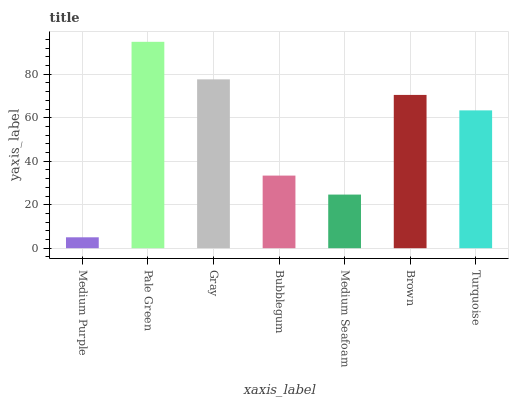Is Medium Purple the minimum?
Answer yes or no. Yes. Is Pale Green the maximum?
Answer yes or no. Yes. Is Gray the minimum?
Answer yes or no. No. Is Gray the maximum?
Answer yes or no. No. Is Pale Green greater than Gray?
Answer yes or no. Yes. Is Gray less than Pale Green?
Answer yes or no. Yes. Is Gray greater than Pale Green?
Answer yes or no. No. Is Pale Green less than Gray?
Answer yes or no. No. Is Turquoise the high median?
Answer yes or no. Yes. Is Turquoise the low median?
Answer yes or no. Yes. Is Gray the high median?
Answer yes or no. No. Is Bubblegum the low median?
Answer yes or no. No. 